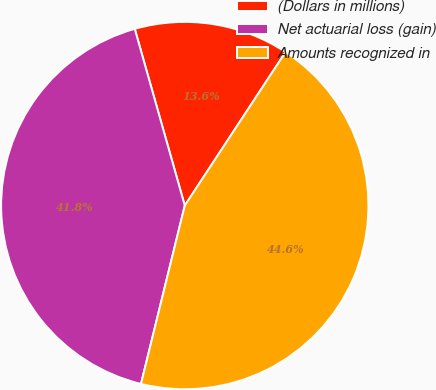Convert chart. <chart><loc_0><loc_0><loc_500><loc_500><pie_chart><fcel>(Dollars in millions)<fcel>Net actuarial loss (gain)<fcel>Amounts recognized in<nl><fcel>13.64%<fcel>41.78%<fcel>44.59%<nl></chart> 